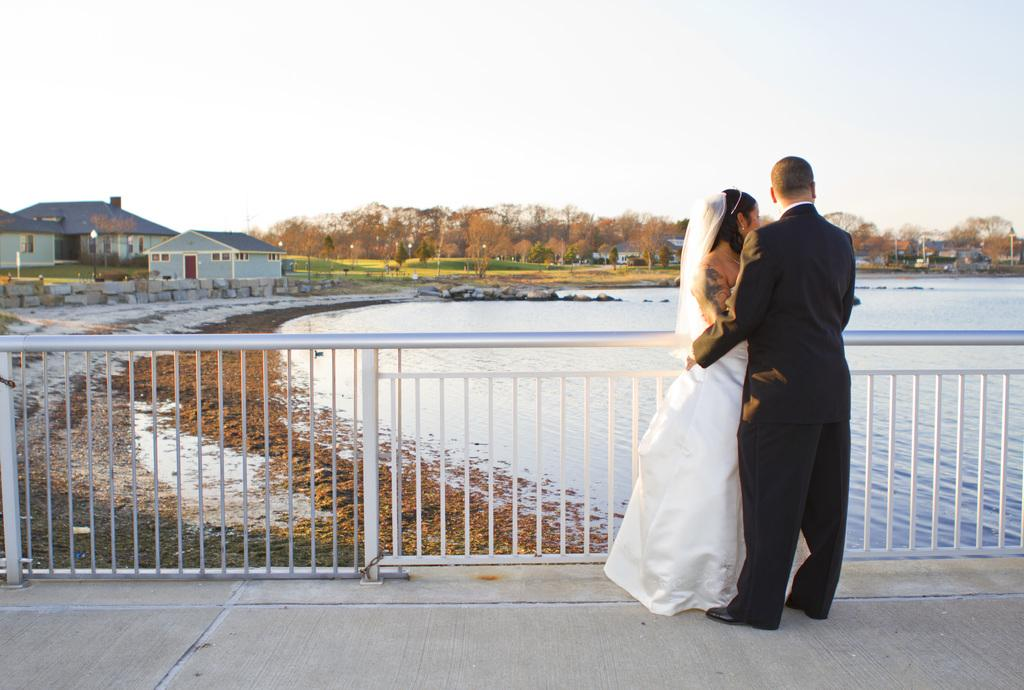What are the two people in the image doing? There is a man and a woman on the road in the image. What can be seen in the background of the image? The sky is visible in the background of the image. What type of structure is present in the image? There are houses in the image. What natural elements can be seen in the image? There are trees, grass, and water visible in the image. What man-made objects are present in the image? There is a fence, poles, and lights in the image. What verse is the cow reciting in the image? There is no cow present in the image, and therefore no verse can be recited. 